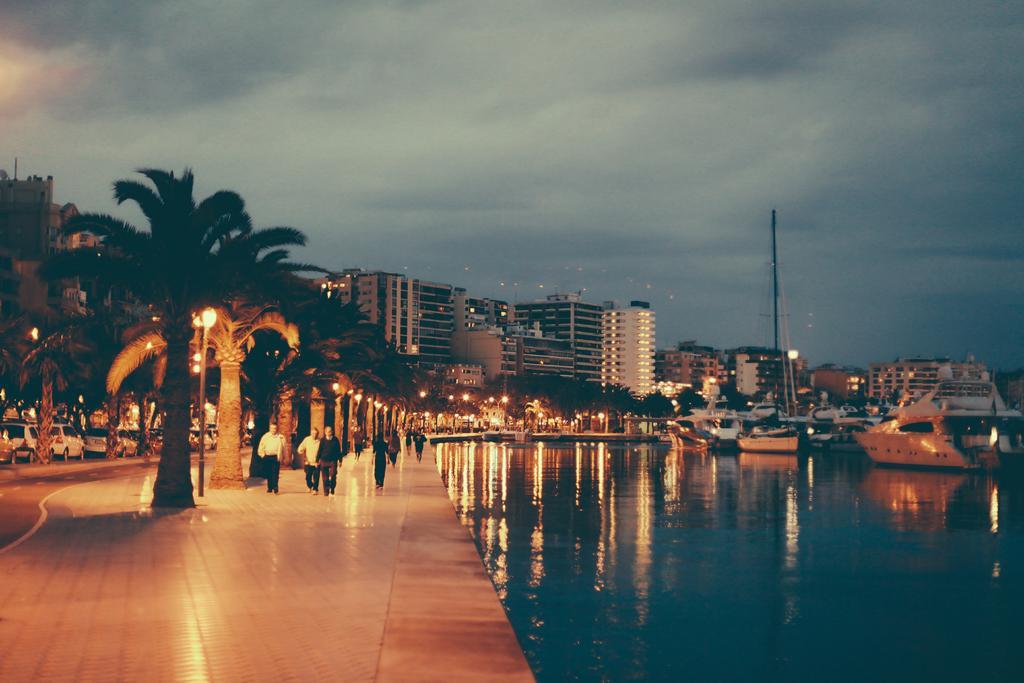Can you describe this image briefly? In this image I can see water on the right side and on it I can see few boats. On the left side of this image I can see number of people, number of trees, street lights and few vehicles on the road. In the background I can see number of buildings, clouds and the sky. 